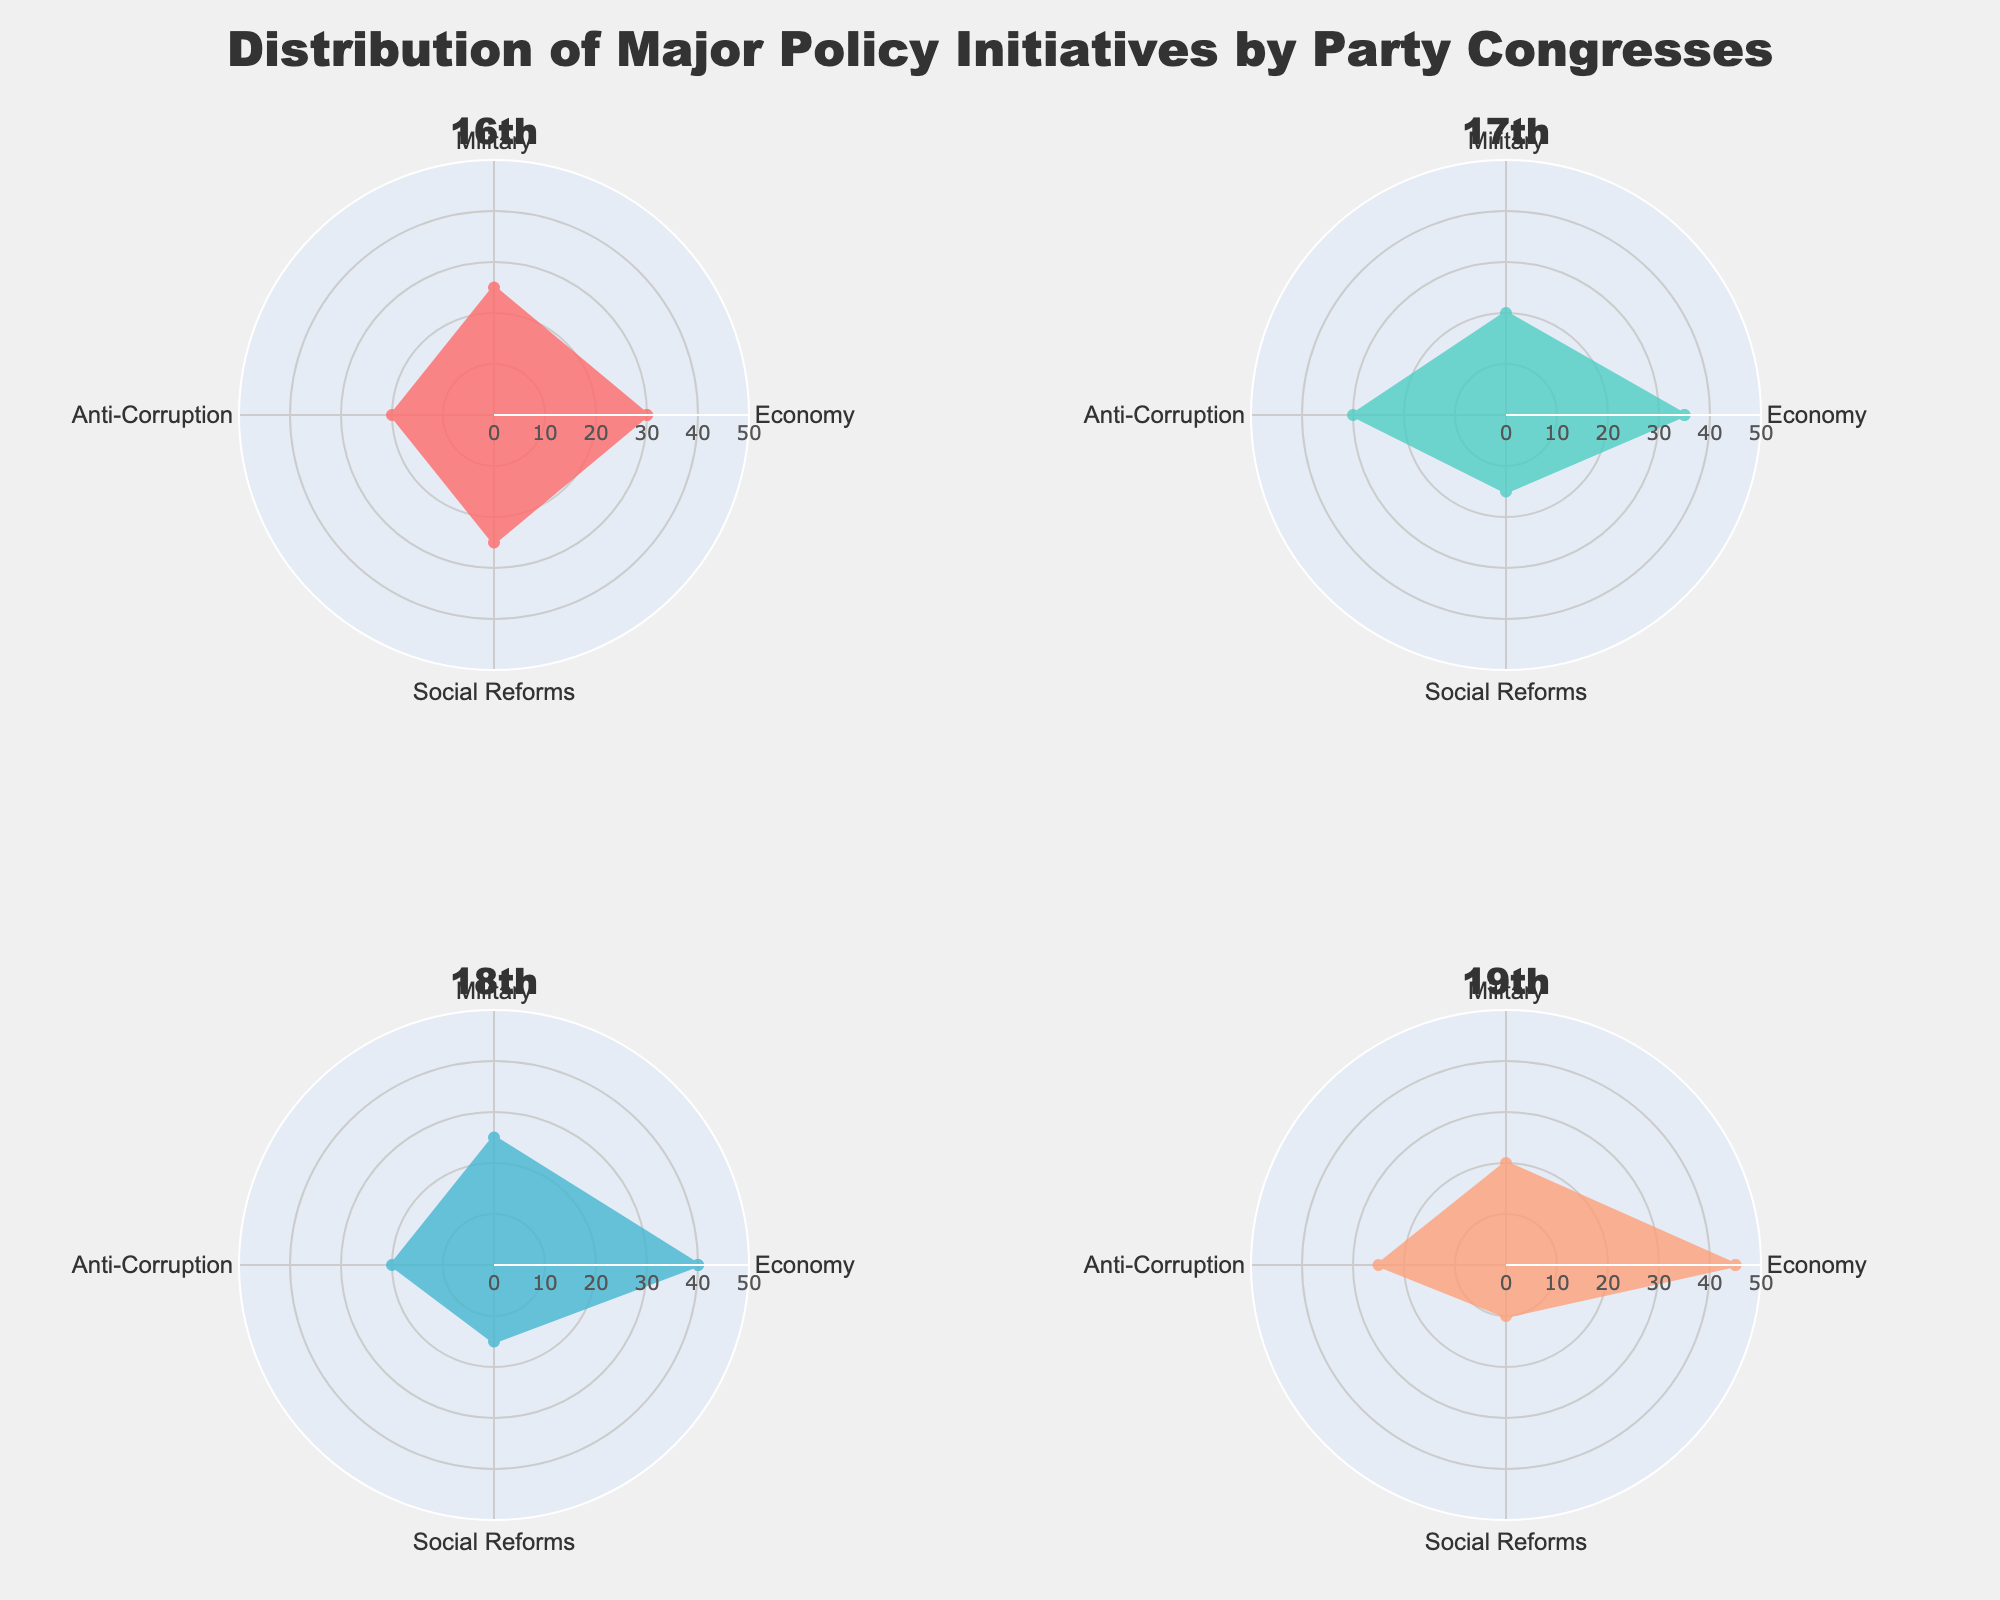what is the title of this figure? The title is often positioned at the top center of the figure. In this case, the title is also described in the code provided: 'Distribution of Major Policy Initiatives by Party Congresses'.
Answer: Distribution of Major Policy Initiatives by Party Congresses Which Party Congress had the highest focus on the economy? By comparing the lengths of the segments representing 'Economy' across all Party Congresses, we can see that the 19th Party Congress had the highest value at 45%.
Answer: 19th What was the difference in anti-corruption focus between the 17th and 19th Party Congresses? From the visual segments for 'Anti-Corruption', the 17th Party Congress had a value of 30%, and the 19th Party Congress had a value of 25%. The difference is calculated as 30% - 25%.
Answer: 5% What categories had the smallest share in the 19th Party Congress? Observing the segments of the 19th Party Congress, the smallest segment corresponds to 'Social Reforms' at 10%.
Answer: Social Reforms Which category saw a continuous increase in focus from the 16th to the 19th Party Congresses? By visual inspection of the segments for each Party Congress from 16th to 19th, the 'Economy' category continuously increased from 30% to 45%.
Answer: Economy What's the average focus on social reforms across all Party Congresses? Sum the values for 'Social Reforms' across all Party Congresses: 25 + 15 + 15 + 10. The total is 65. Then, divide by the number of Party Congresses (4): 65/4 = 16.25.
Answer: 16.25 Which Party Congress had the closest focus percentages between economy and military? For each Party Congress:
- 16th: Economy (30%) and Military (25%) - Difference: 5%
- 17th: Economy (35%) and Military (20%) - Difference: 15%
- 18th: Economy (40%) and Military (25%) - Difference: 15%
- 19th: Economy (45%) and Military (20%) - Difference: 25%
The 16th Party Congress had the smallest difference of 5%.
Answer: 16th Compare the focus on social reforms between the 16th and 18th Party Congresses. Which one had the higher focus? Comparing the 'Social Reforms' segments, the 16th Party Congress had 25% while the 18th had 15%. The 16th had a higher focus.
Answer: 16th What is the general trend in military focus from the 16th to the 19th Party Congresses? Observing the segments for 'Military' across the Party Congresses: 
-16th: 25%
-17th: 20%
-18th: 25%
-19th: 20%
There is no clear increasing or decreasing trend, but it fluctuates between 20% and 25%.
Answer: Fluctuating between 20% and 25% How does the focus on anti-corruption in the 17th Party Congress compare to the 18th Party Congress? The segments for 'Anti-Corruption' show that the 17th had 30%, while the 18th had 20%. Therefore, the 17th had a higher focus by 10%.
Answer: 10% higher 